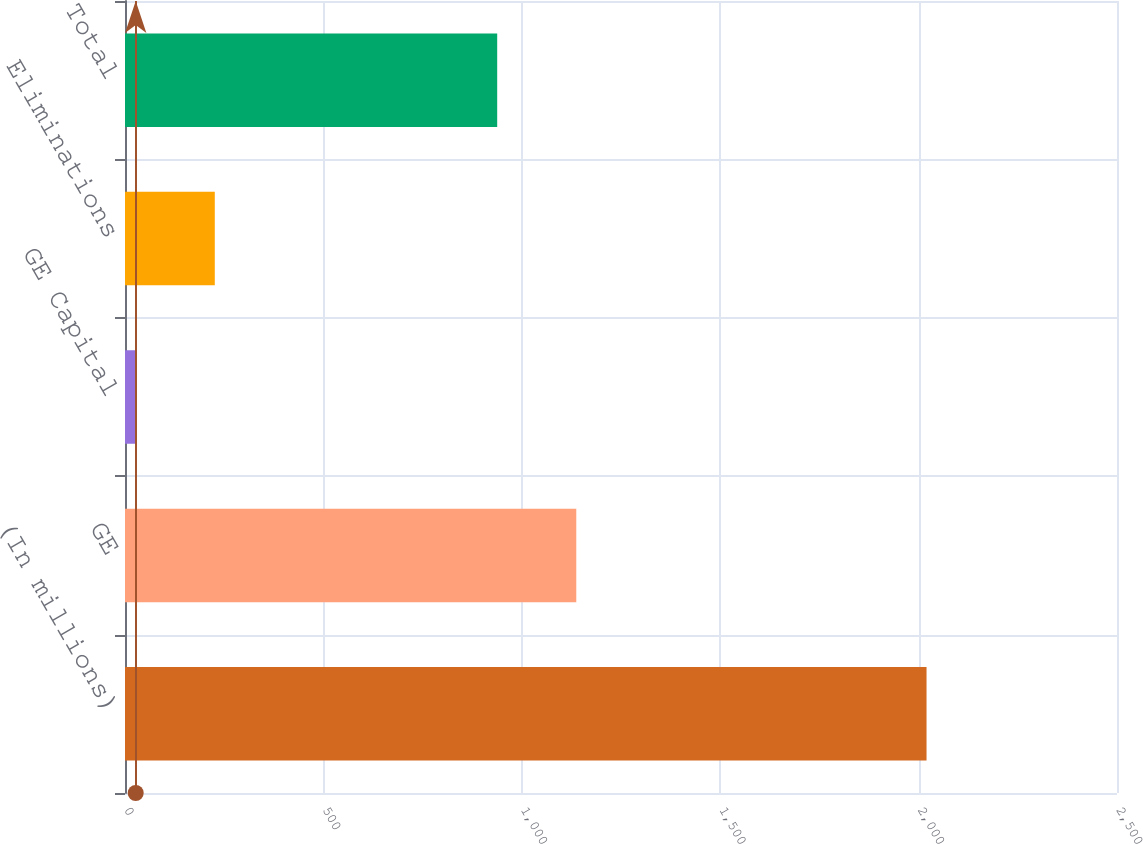<chart> <loc_0><loc_0><loc_500><loc_500><bar_chart><fcel>(In millions)<fcel>GE<fcel>GE Capital<fcel>Eliminations<fcel>Total<nl><fcel>2020<fcel>1137.3<fcel>27<fcel>226.3<fcel>938<nl></chart> 